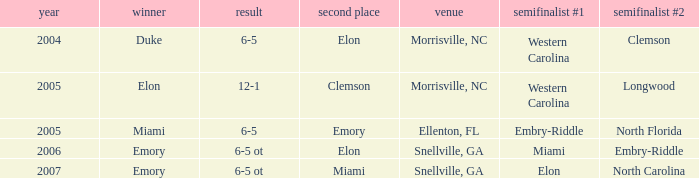How many teams were listed as runner up in 2005 and there the first semi finalist was Western Carolina? 1.0. 